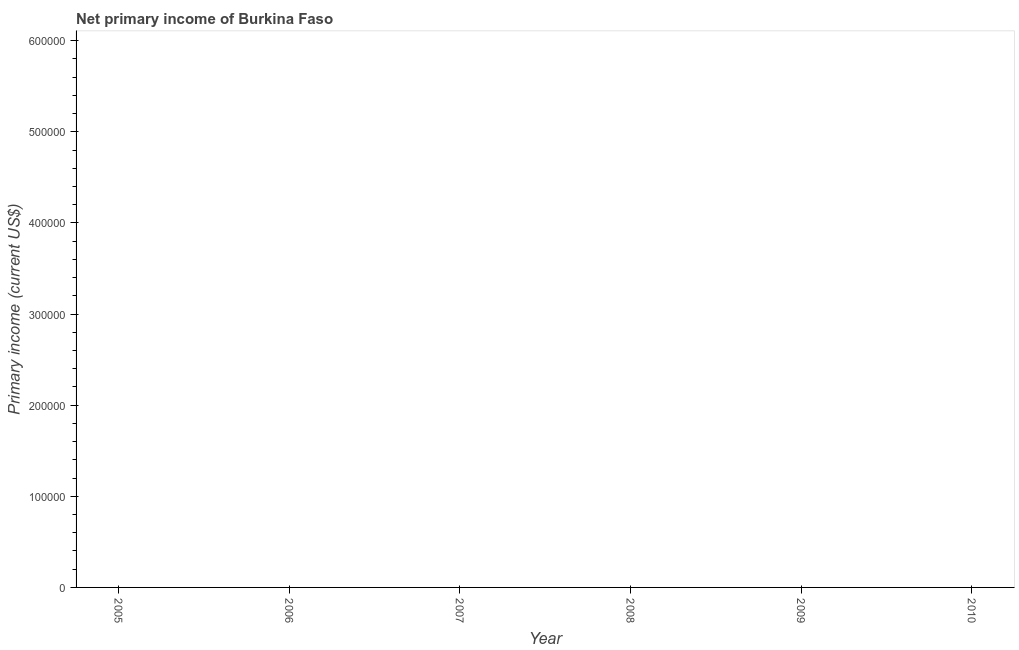Across all years, what is the minimum amount of primary income?
Your answer should be compact. 0. What is the sum of the amount of primary income?
Your answer should be very brief. 0. In how many years, is the amount of primary income greater than 500000 US$?
Provide a succinct answer. 0. Does the amount of primary income monotonically increase over the years?
Make the answer very short. No. How many years are there in the graph?
Provide a short and direct response. 6. What is the difference between two consecutive major ticks on the Y-axis?
Your answer should be very brief. 1.00e+05. Are the values on the major ticks of Y-axis written in scientific E-notation?
Give a very brief answer. No. What is the title of the graph?
Offer a terse response. Net primary income of Burkina Faso. What is the label or title of the Y-axis?
Provide a succinct answer. Primary income (current US$). What is the Primary income (current US$) in 2005?
Your response must be concise. 0. What is the Primary income (current US$) in 2006?
Your answer should be very brief. 0. What is the Primary income (current US$) in 2008?
Offer a terse response. 0. What is the Primary income (current US$) in 2009?
Offer a very short reply. 0. 